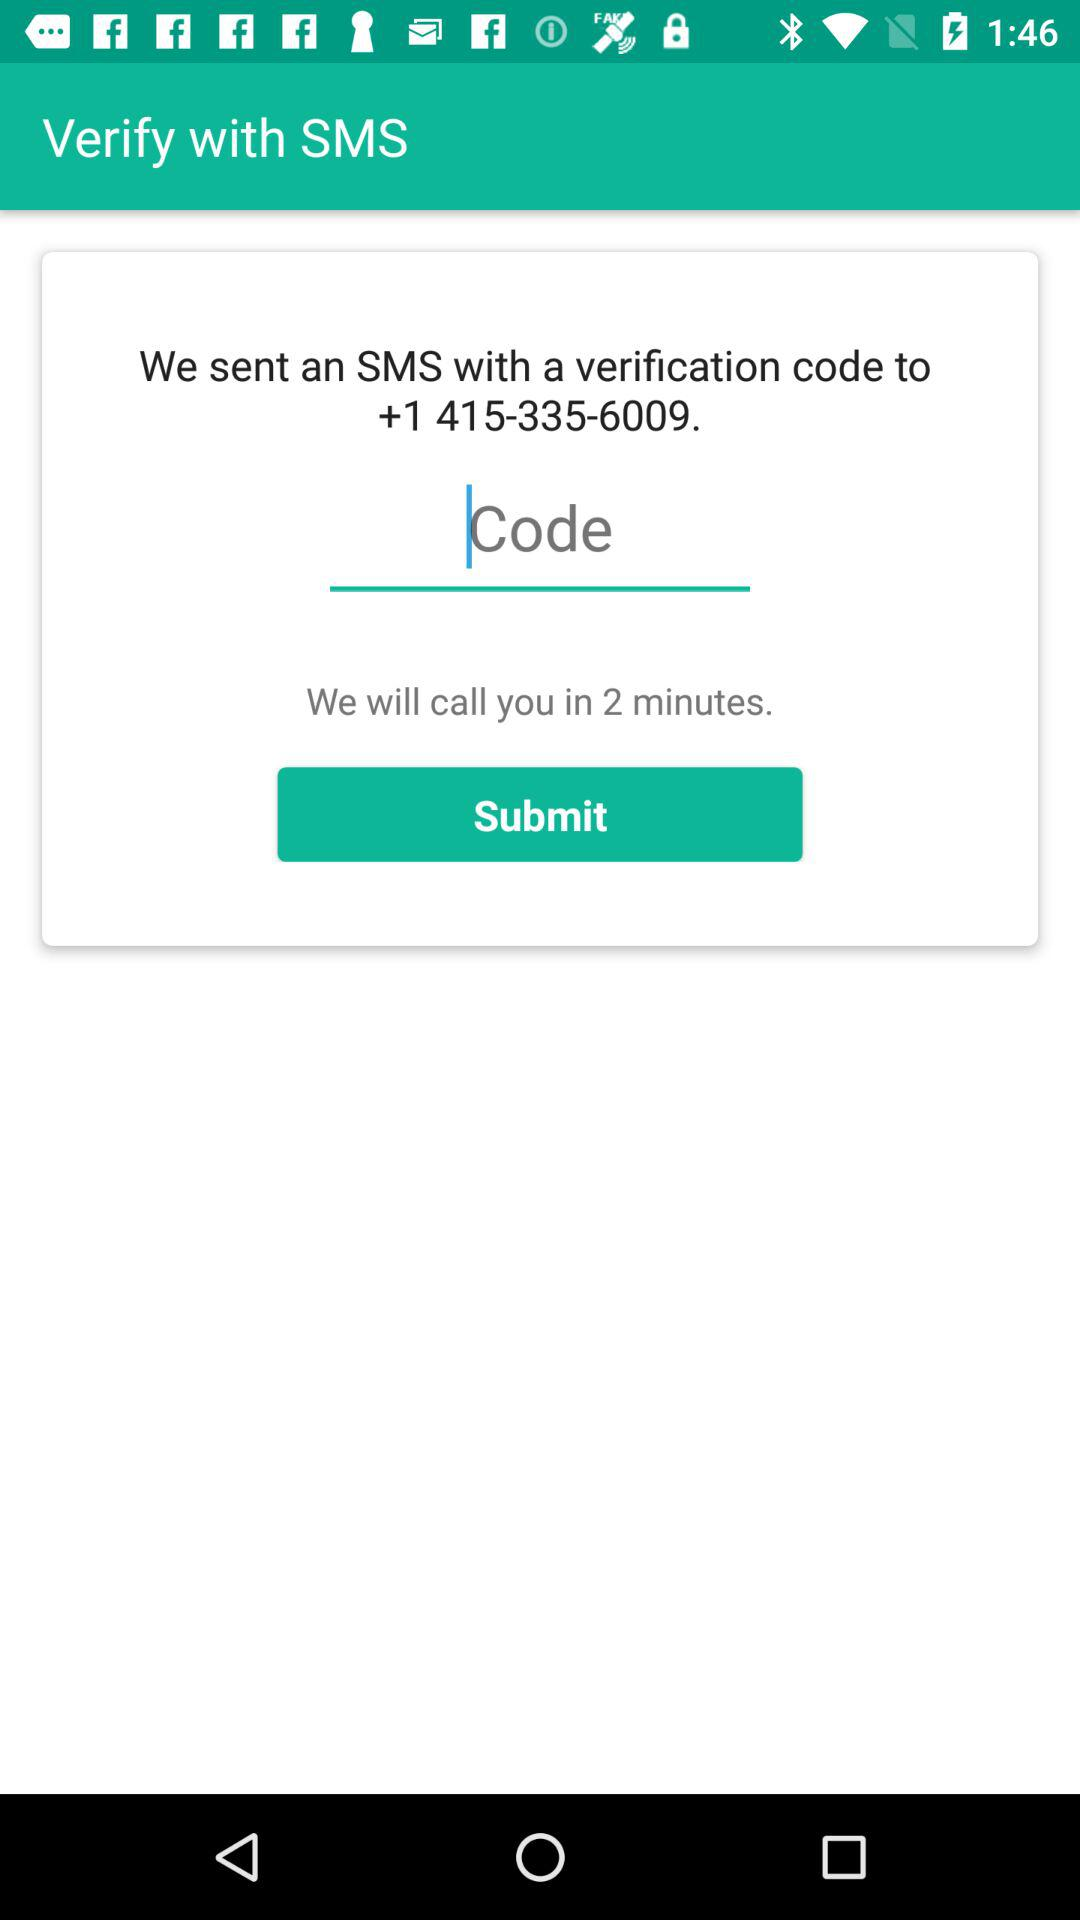How many minutes until I can call instead of entering a code?
Answer the question using a single word or phrase. 2 